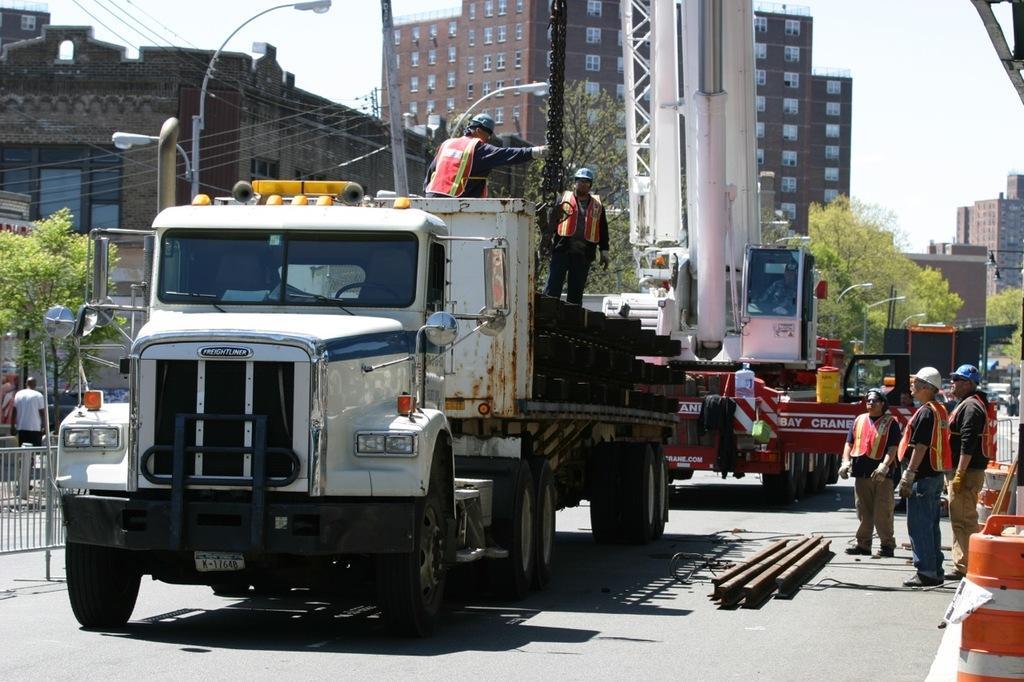How would you summarize this image in a sentence or two? In this image we can see the people wearing the helmets and standing. We can also see the vehicles and some other objects. We can see the light poles, electrical pole, wires, trees, buildings and also the barrier. On the left we can see a person. We can also see the sky. At the bottom we can see the road. 